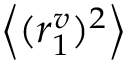<formula> <loc_0><loc_0><loc_500><loc_500>\left < ( r _ { 1 } ^ { v } ) ^ { 2 } \right ></formula> 